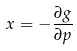Convert formula to latex. <formula><loc_0><loc_0><loc_500><loc_500>x = - \frac { \partial g } { \partial p }</formula> 